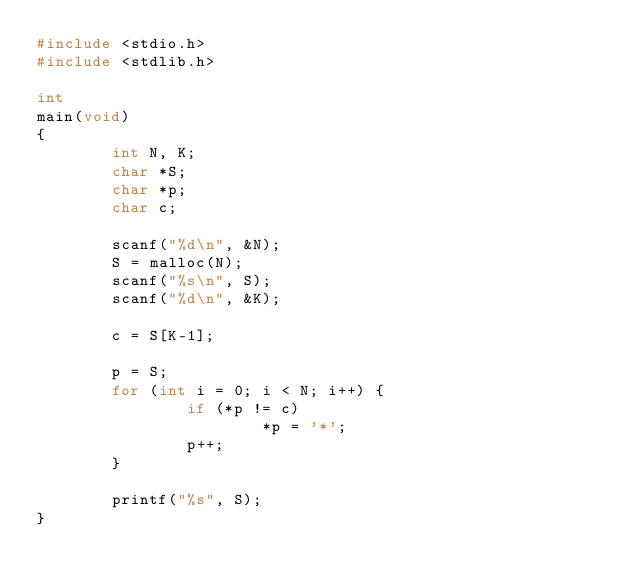Convert code to text. <code><loc_0><loc_0><loc_500><loc_500><_C_>#include <stdio.h>
#include <stdlib.h>

int
main(void)
{
        int N, K;
        char *S;
        char *p;
        char c;

        scanf("%d\n", &N);
        S = malloc(N);
        scanf("%s\n", S);
        scanf("%d\n", &K);

        c = S[K-1];

        p = S;
        for (int i = 0; i < N; i++) {
                if (*p != c)
                        *p = '*';
                p++;
        }

        printf("%s", S);
}
</code> 